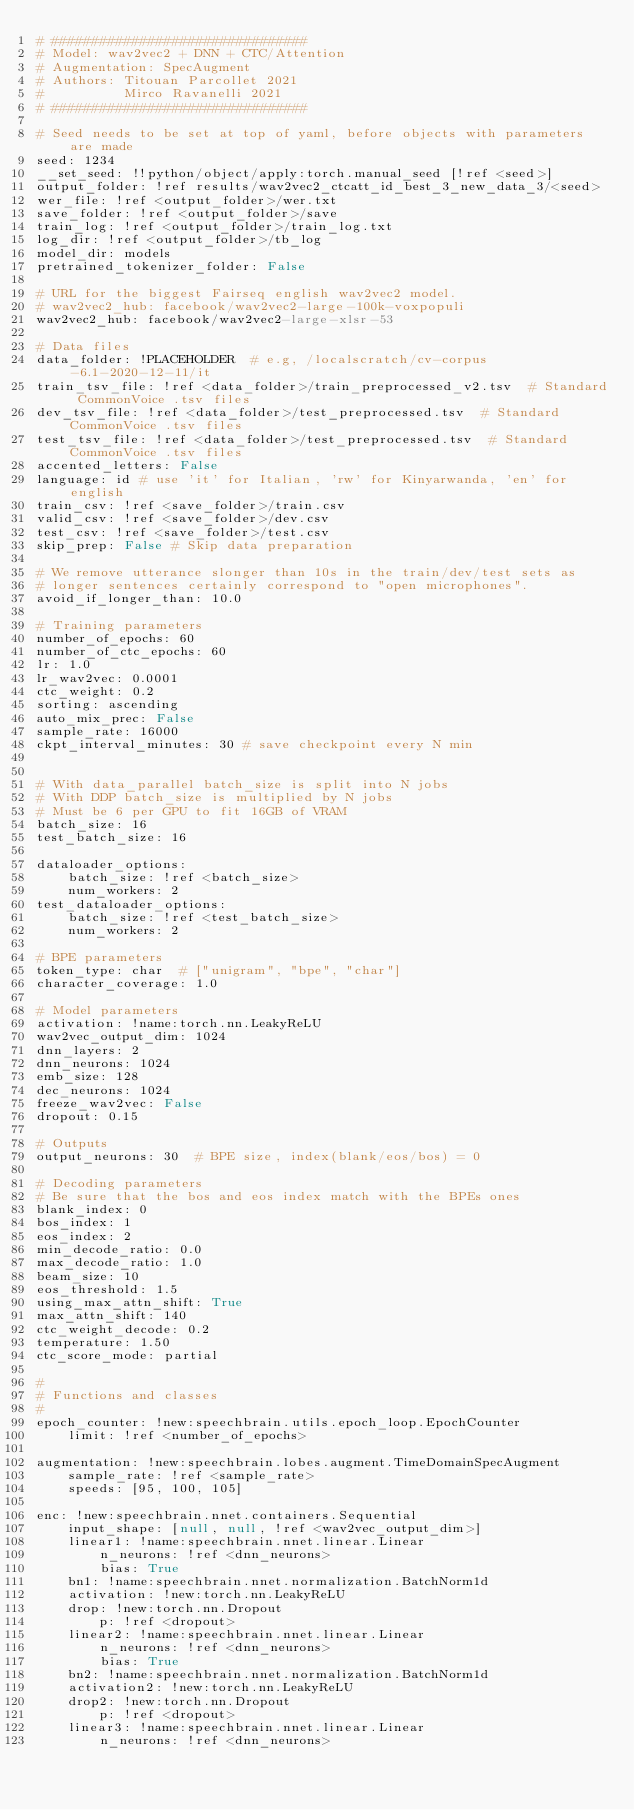<code> <loc_0><loc_0><loc_500><loc_500><_YAML_># ################################
# Model: wav2vec2 + DNN + CTC/Attention
# Augmentation: SpecAugment
# Authors: Titouan Parcollet 2021
#          Mirco Ravanelli 2021
# ################################

# Seed needs to be set at top of yaml, before objects with parameters are made
seed: 1234
__set_seed: !!python/object/apply:torch.manual_seed [!ref <seed>]
output_folder: !ref results/wav2vec2_ctcatt_id_best_3_new_data_3/<seed>
wer_file: !ref <output_folder>/wer.txt
save_folder: !ref <output_folder>/save
train_log: !ref <output_folder>/train_log.txt
log_dir: !ref <output_folder>/tb_log
model_dir: models
pretrained_tokenizer_folder: False

# URL for the biggest Fairseq english wav2vec2 model.
# wav2vec2_hub: facebook/wav2vec2-large-100k-voxpopuli
wav2vec2_hub: facebook/wav2vec2-large-xlsr-53

# Data files
data_folder: !PLACEHOLDER  # e.g, /localscratch/cv-corpus-6.1-2020-12-11/it
train_tsv_file: !ref <data_folder>/train_preprocessed_v2.tsv  # Standard CommonVoice .tsv files
dev_tsv_file: !ref <data_folder>/test_preprocessed.tsv  # Standard CommonVoice .tsv files
test_tsv_file: !ref <data_folder>/test_preprocessed.tsv  # Standard CommonVoice .tsv files
accented_letters: False
language: id # use 'it' for Italian, 'rw' for Kinyarwanda, 'en' for english
train_csv: !ref <save_folder>/train.csv
valid_csv: !ref <save_folder>/dev.csv
test_csv: !ref <save_folder>/test.csv
skip_prep: False # Skip data preparation

# We remove utterance slonger than 10s in the train/dev/test sets as
# longer sentences certainly correspond to "open microphones".
avoid_if_longer_than: 10.0

# Training parameters
number_of_epochs: 60
number_of_ctc_epochs: 60
lr: 1.0
lr_wav2vec: 0.0001
ctc_weight: 0.2
sorting: ascending
auto_mix_prec: False
sample_rate: 16000
ckpt_interval_minutes: 30 # save checkpoint every N min


# With data_parallel batch_size is split into N jobs
# With DDP batch_size is multiplied by N jobs
# Must be 6 per GPU to fit 16GB of VRAM
batch_size: 16
test_batch_size: 16

dataloader_options:
    batch_size: !ref <batch_size>
    num_workers: 2
test_dataloader_options:
    batch_size: !ref <test_batch_size>
    num_workers: 2

# BPE parameters
token_type: char  # ["unigram", "bpe", "char"]
character_coverage: 1.0

# Model parameters
activation: !name:torch.nn.LeakyReLU
wav2vec_output_dim: 1024
dnn_layers: 2
dnn_neurons: 1024
emb_size: 128
dec_neurons: 1024
freeze_wav2vec: False
dropout: 0.15

# Outputs
output_neurons: 30  # BPE size, index(blank/eos/bos) = 0

# Decoding parameters
# Be sure that the bos and eos index match with the BPEs ones
blank_index: 0
bos_index: 1
eos_index: 2
min_decode_ratio: 0.0
max_decode_ratio: 1.0
beam_size: 10
eos_threshold: 1.5
using_max_attn_shift: True
max_attn_shift: 140
ctc_weight_decode: 0.2
temperature: 1.50
ctc_score_mode: partial

#
# Functions and classes
#
epoch_counter: !new:speechbrain.utils.epoch_loop.EpochCounter
    limit: !ref <number_of_epochs>

augmentation: !new:speechbrain.lobes.augment.TimeDomainSpecAugment
    sample_rate: !ref <sample_rate>
    speeds: [95, 100, 105]

enc: !new:speechbrain.nnet.containers.Sequential
    input_shape: [null, null, !ref <wav2vec_output_dim>]
    linear1: !name:speechbrain.nnet.linear.Linear
        n_neurons: !ref <dnn_neurons>
        bias: True
    bn1: !name:speechbrain.nnet.normalization.BatchNorm1d
    activation: !new:torch.nn.LeakyReLU
    drop: !new:torch.nn.Dropout
        p: !ref <dropout>
    linear2: !name:speechbrain.nnet.linear.Linear
        n_neurons: !ref <dnn_neurons>
        bias: True
    bn2: !name:speechbrain.nnet.normalization.BatchNorm1d
    activation2: !new:torch.nn.LeakyReLU
    drop2: !new:torch.nn.Dropout
        p: !ref <dropout>
    linear3: !name:speechbrain.nnet.linear.Linear
        n_neurons: !ref <dnn_neurons></code> 